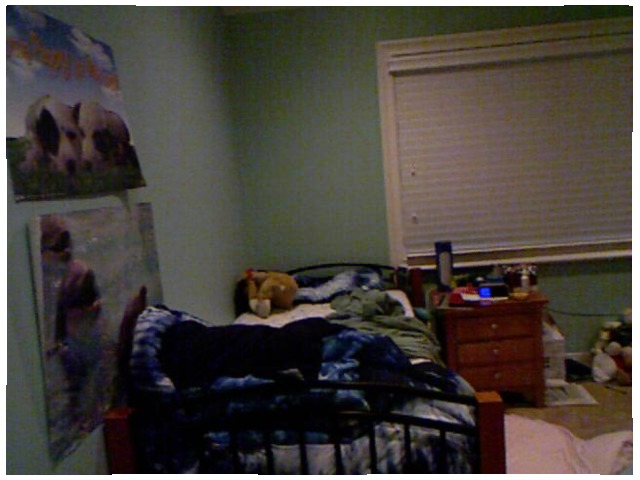<image>
Is the poster to the right of the poster? No. The poster is not to the right of the poster. The horizontal positioning shows a different relationship. Is the bed to the right of the table? No. The bed is not to the right of the table. The horizontal positioning shows a different relationship. 